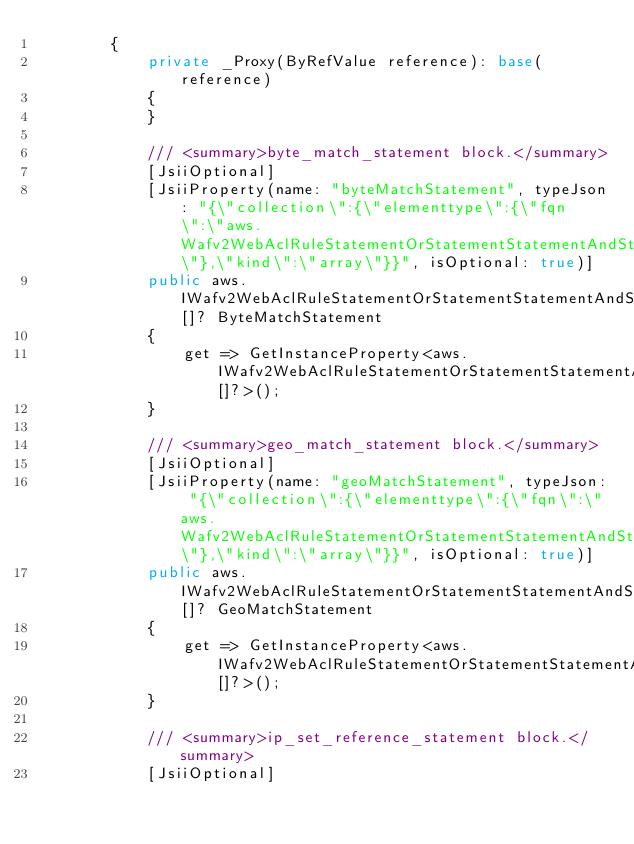Convert code to text. <code><loc_0><loc_0><loc_500><loc_500><_C#_>        {
            private _Proxy(ByRefValue reference): base(reference)
            {
            }

            /// <summary>byte_match_statement block.</summary>
            [JsiiOptional]
            [JsiiProperty(name: "byteMatchStatement", typeJson: "{\"collection\":{\"elementtype\":{\"fqn\":\"aws.Wafv2WebAclRuleStatementOrStatementStatementAndStatementStatementAndStatementStatementByteMatchStatement\"},\"kind\":\"array\"}}", isOptional: true)]
            public aws.IWafv2WebAclRuleStatementOrStatementStatementAndStatementStatementAndStatementStatementByteMatchStatement[]? ByteMatchStatement
            {
                get => GetInstanceProperty<aws.IWafv2WebAclRuleStatementOrStatementStatementAndStatementStatementAndStatementStatementByteMatchStatement[]?>();
            }

            /// <summary>geo_match_statement block.</summary>
            [JsiiOptional]
            [JsiiProperty(name: "geoMatchStatement", typeJson: "{\"collection\":{\"elementtype\":{\"fqn\":\"aws.Wafv2WebAclRuleStatementOrStatementStatementAndStatementStatementAndStatementStatementGeoMatchStatement\"},\"kind\":\"array\"}}", isOptional: true)]
            public aws.IWafv2WebAclRuleStatementOrStatementStatementAndStatementStatementAndStatementStatementGeoMatchStatement[]? GeoMatchStatement
            {
                get => GetInstanceProperty<aws.IWafv2WebAclRuleStatementOrStatementStatementAndStatementStatementAndStatementStatementGeoMatchStatement[]?>();
            }

            /// <summary>ip_set_reference_statement block.</summary>
            [JsiiOptional]</code> 